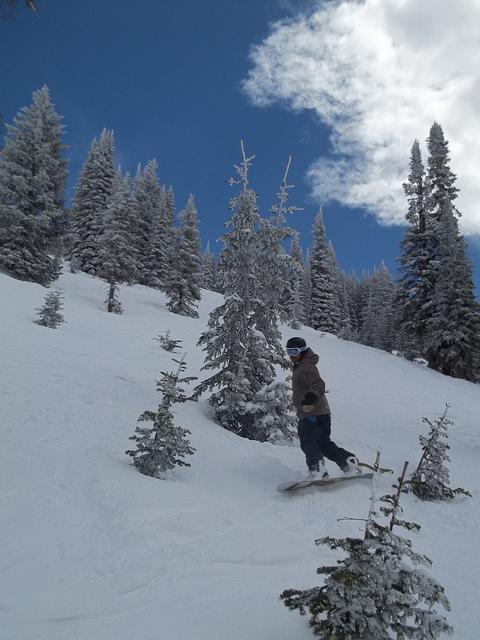Are the trees covered in snow?
Short answer required. Yes. Is there a white cloud in the sky?
Concise answer only. Yes. What is in the snow?
Give a very brief answer. Trees. What is the pastime taking place?
Short answer required. Snowboarding. What is the person doing?
Short answer required. Snowboarding. What number of trees are on the side of the hillside?
Concise answer only. 15. 